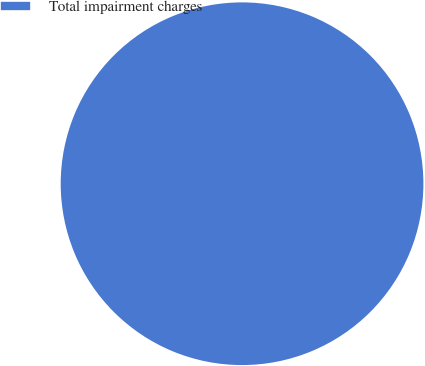Convert chart to OTSL. <chart><loc_0><loc_0><loc_500><loc_500><pie_chart><fcel>Total impairment charges<nl><fcel>100.0%<nl></chart> 